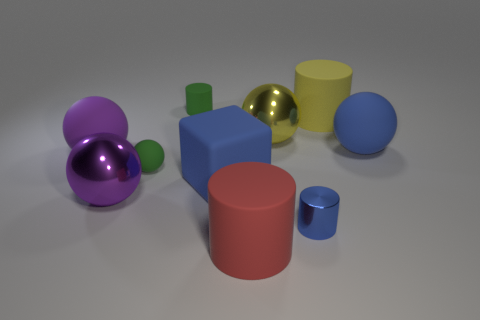Subtract all red matte cylinders. How many cylinders are left? 3 Subtract all blue cylinders. How many purple balls are left? 2 Subtract 3 spheres. How many spheres are left? 2 Subtract all red cylinders. How many cylinders are left? 3 Subtract all cylinders. How many objects are left? 6 Subtract all gray cubes. Subtract all blue balls. How many cubes are left? 1 Subtract all big rubber spheres. Subtract all big purple balls. How many objects are left? 6 Add 6 small blue metal cylinders. How many small blue metal cylinders are left? 7 Add 3 large purple spheres. How many large purple spheres exist? 5 Subtract 1 green balls. How many objects are left? 9 